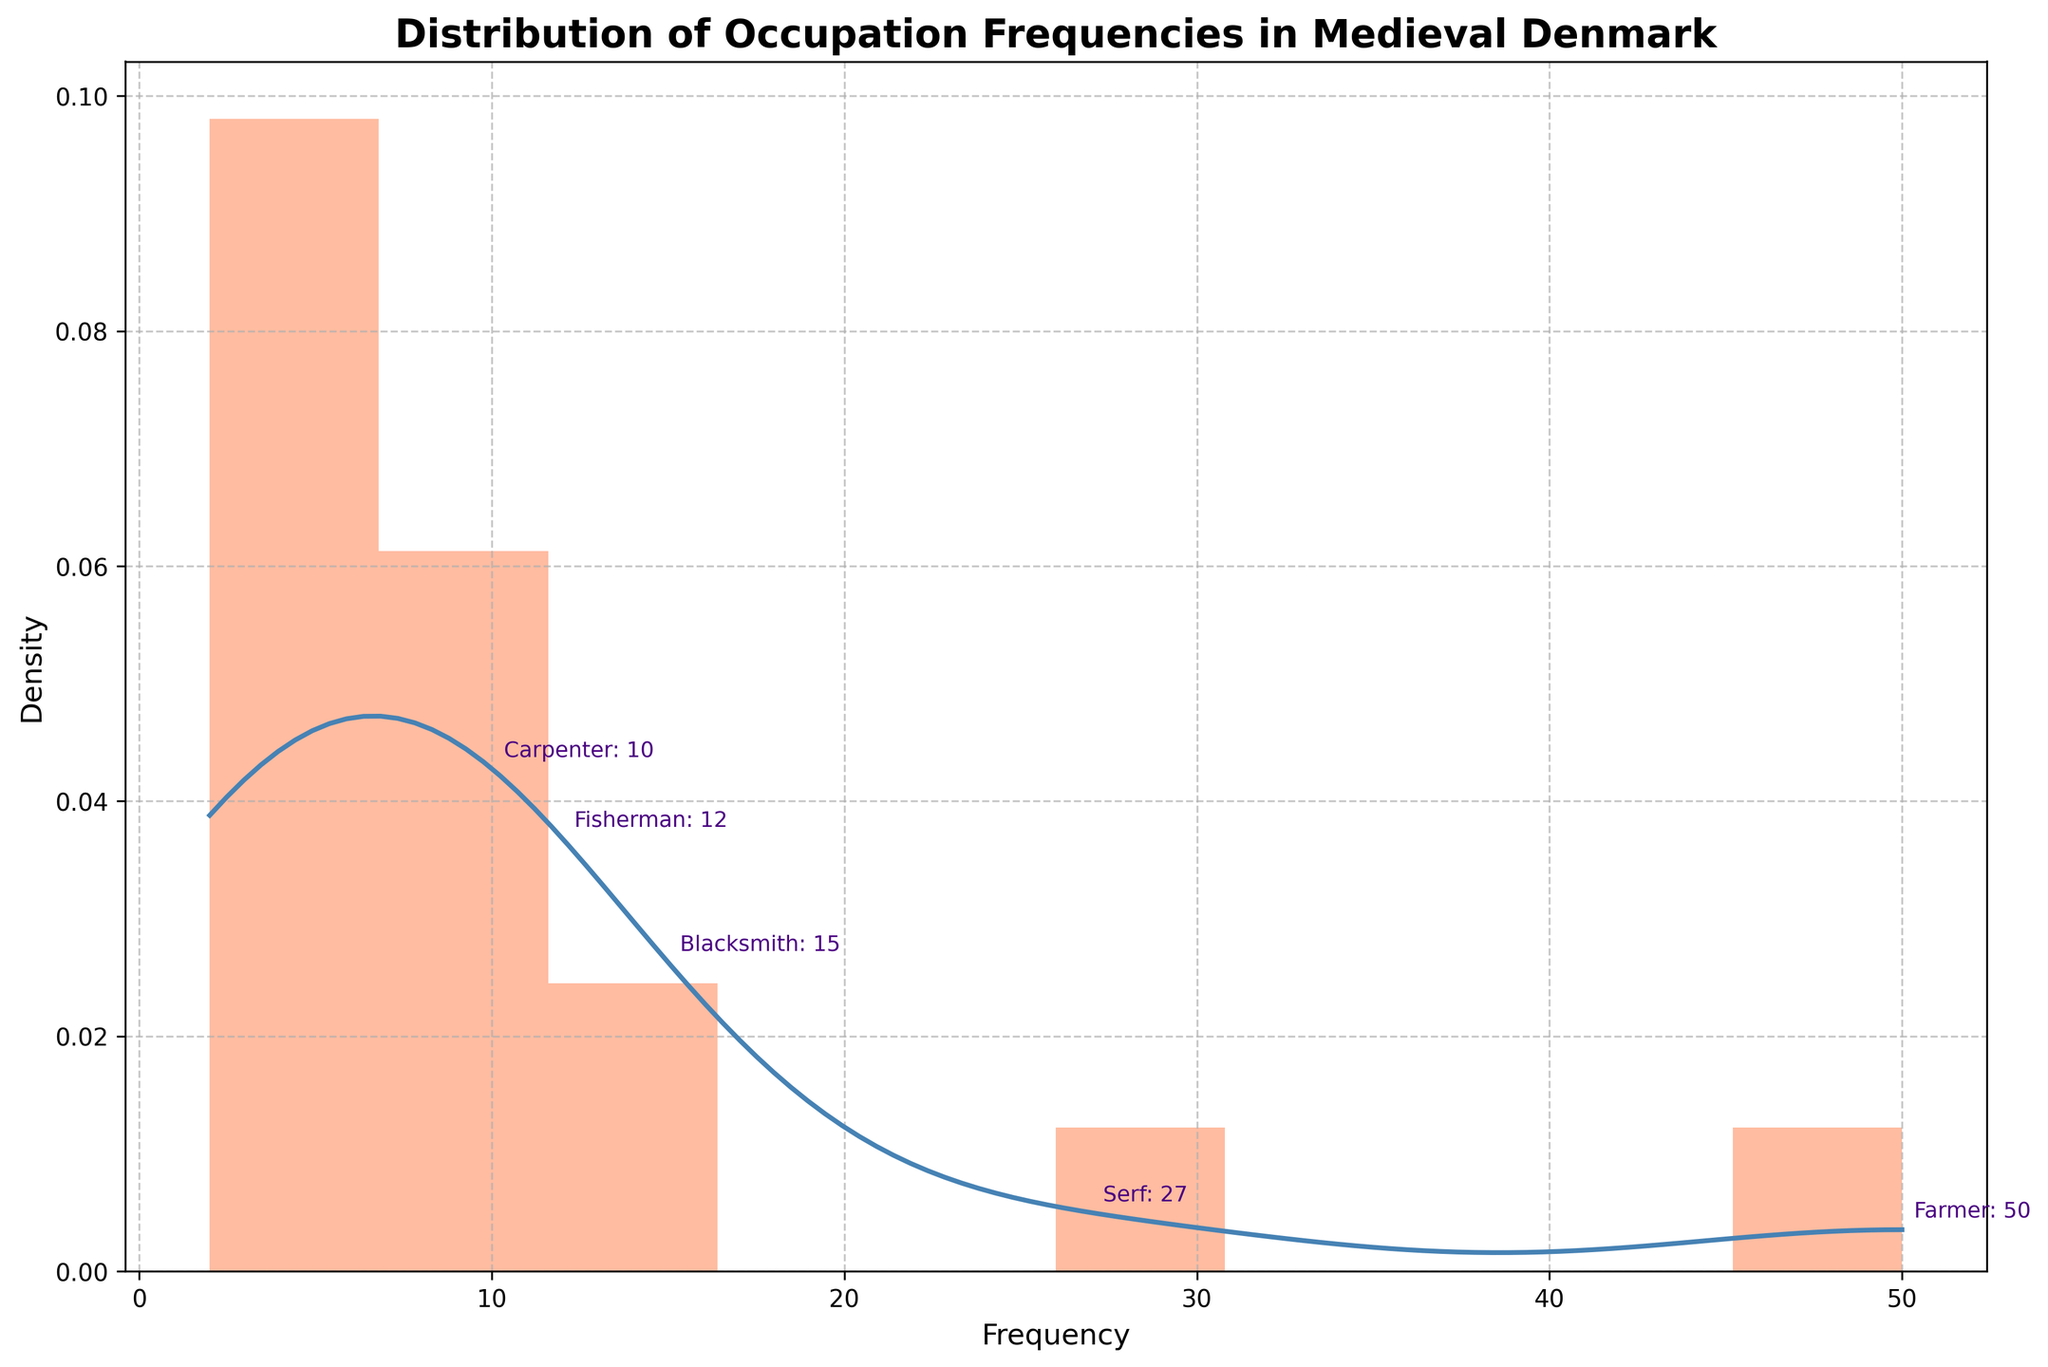What is the title of the plot? The title is displayed at the top of the plot, indicating what the figure represents.
Answer: Distribution of Occupation Frequencies in Medieval Denmark What do the x-axis and y-axis represent? The x-axis represents the frequency of occupations, and the y-axis represents the density of those frequencies. This can be inferred from the axis labels.
Answer: Frequency (x-axis) and Density (y-axis) Which occupation has the highest frequency? By looking at the annotations on the plot, it's clear that the highest frequency occupation is denoted at the top of the figure. The annotation with 'Farmer: 50' shows the highest frequency.
Answer: Farmer How many different occupations have a frequency higher than 10? The top section of the histogram and annotations provide a visual clue. Occupations with higher frequencies are easily seen and annotated, making it simple to count.
Answer: 2 (Farmer and Serf) What is the frequency of the occupation with the lowest frequency? The histogram bins and matching density curve show the entire range of frequencies. By examining the lowest bin and confirming with the annotations, we see the smallest frequency.
Answer: 2 (Innkeeper) Which two occupations have the closest frequencies? From the annotations on the plot, we can see occupations with similar frequency values. The closest ones are not hard to pinpoint.
Answer: Cooper and Merchant How many occupations are annotated in the plot? The annotations on the plot, designed to highlight the top frequencies, are easily counted by eye.
Answer: 5 What indicates the spread of the data in the plot? The histogram bins and the Gaussian KDE (Kernel Density Estimate) curve show how spread out the occupation frequencies are. KDE curves provide a smooth estimate of the data's distribution.
Answer: Histogram and KDE curve What is the range of the frequency of occupations? By checking the minimum and maximum bins on the x-axis and confirming with annotations, we identify the range.
Answer: 2 to 50 What visual feature is used to highlight the top occupations? Text annotations are used near the peaks of the KDE curve, denoting the occupation name and its frequency clearly.
Answer: Text annotations 